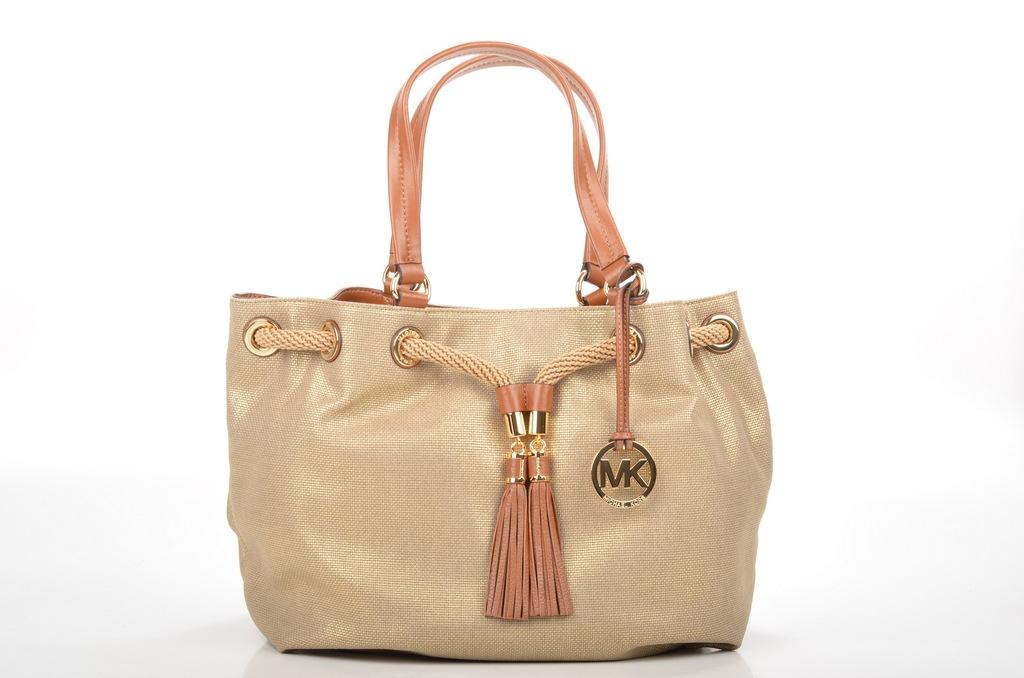What object is present in the image with a brown color? There is a brown bag in the image. What feature is present on the brown bag? The brown bag has an emblem. How can the brown bag be carried? The brown bag has a handle for carrying. What color is the background of the image? The background of the image is white. How many beds are visible in the image? There are no beds present in the image; it features a brown bag with an emblem and handle against a white background. What type of crate is shown next to the brown bag? There is no crate present in the image; it only features the brown bag with an emblem and handle against a white background. 